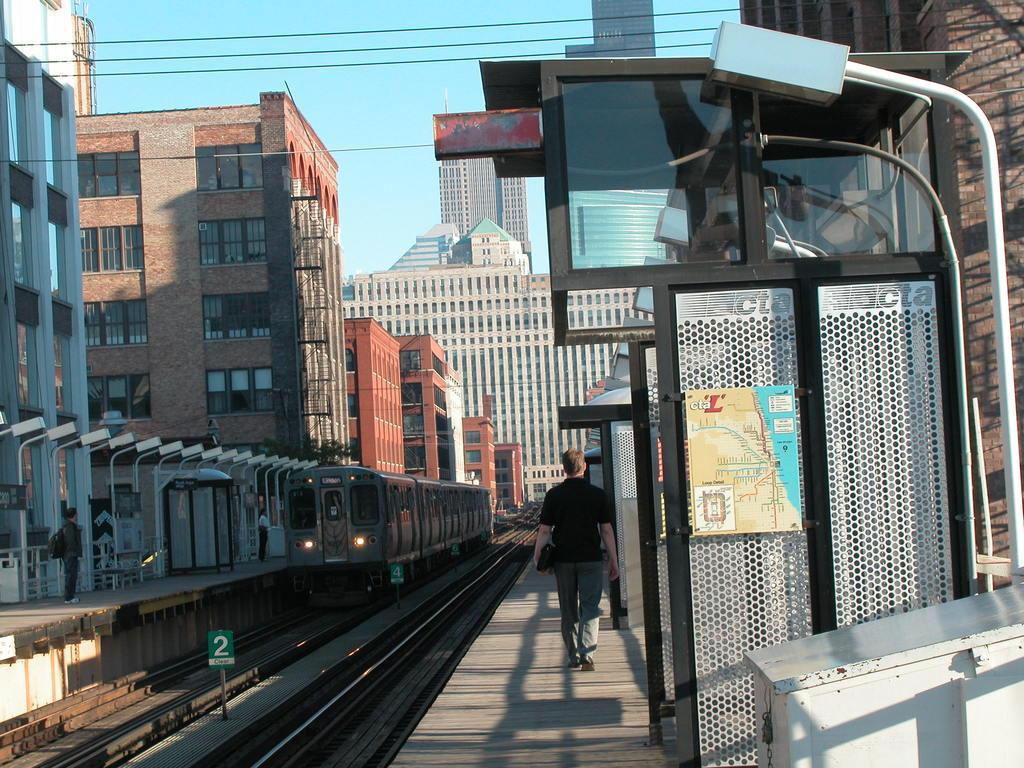In one or two sentences, can you explain what this image depicts? In this image I can see a train on the railway track and another railway track. I can see two platforms on either side of the train and few persons standing on the platforms. I can see few buildings, few light poles, few wires and the sky in the background. 